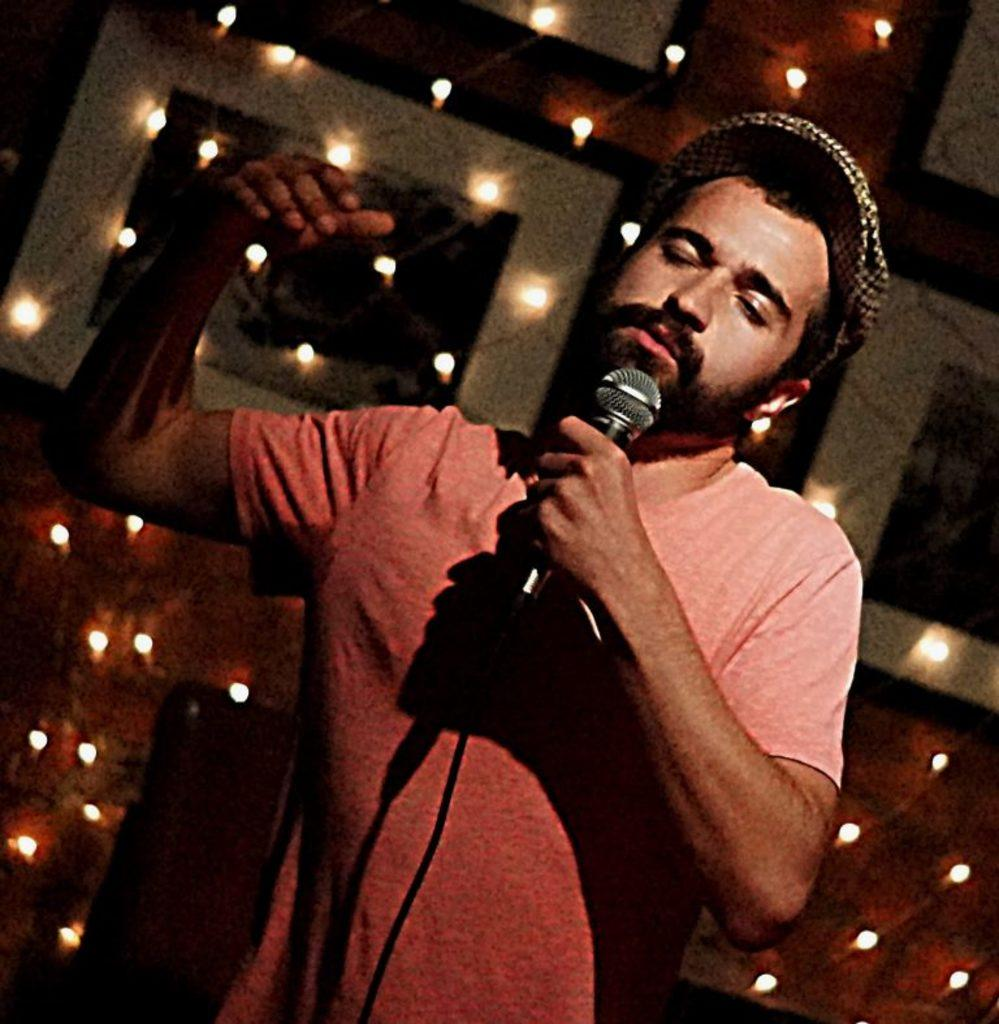What is the man in the image doing? The man is standing in the image and holding a mic. What can be seen at the back side of the image? There are frames and bulbs at the back side of the image. What type of jam is the pig eating in the image? There is no jam or pig present in the image. Is the man in the image an actor? The provided facts do not mention whether the man is an actor or not, so we cannot definitively answer that question. 